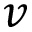Convert formula to latex. <formula><loc_0><loc_0><loc_500><loc_500>v</formula> 